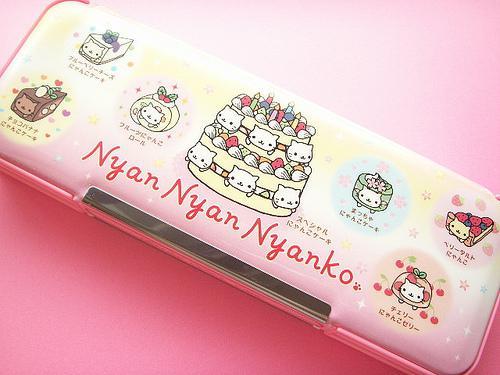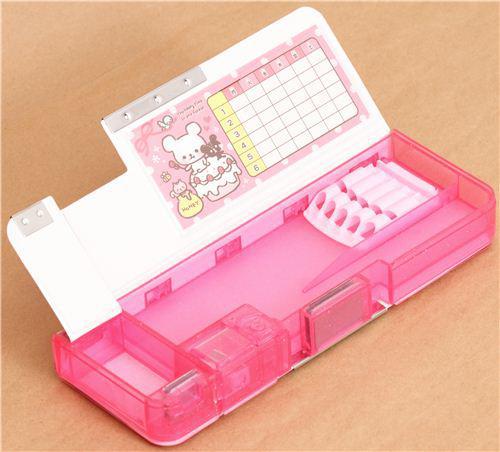The first image is the image on the left, the second image is the image on the right. Examine the images to the left and right. Is the description "The image on the left shows a single pencil case that is closed." accurate? Answer yes or no. Yes. The first image is the image on the left, the second image is the image on the right. Evaluate the accuracy of this statement regarding the images: "There are two open pencil cases.". Is it true? Answer yes or no. No. 